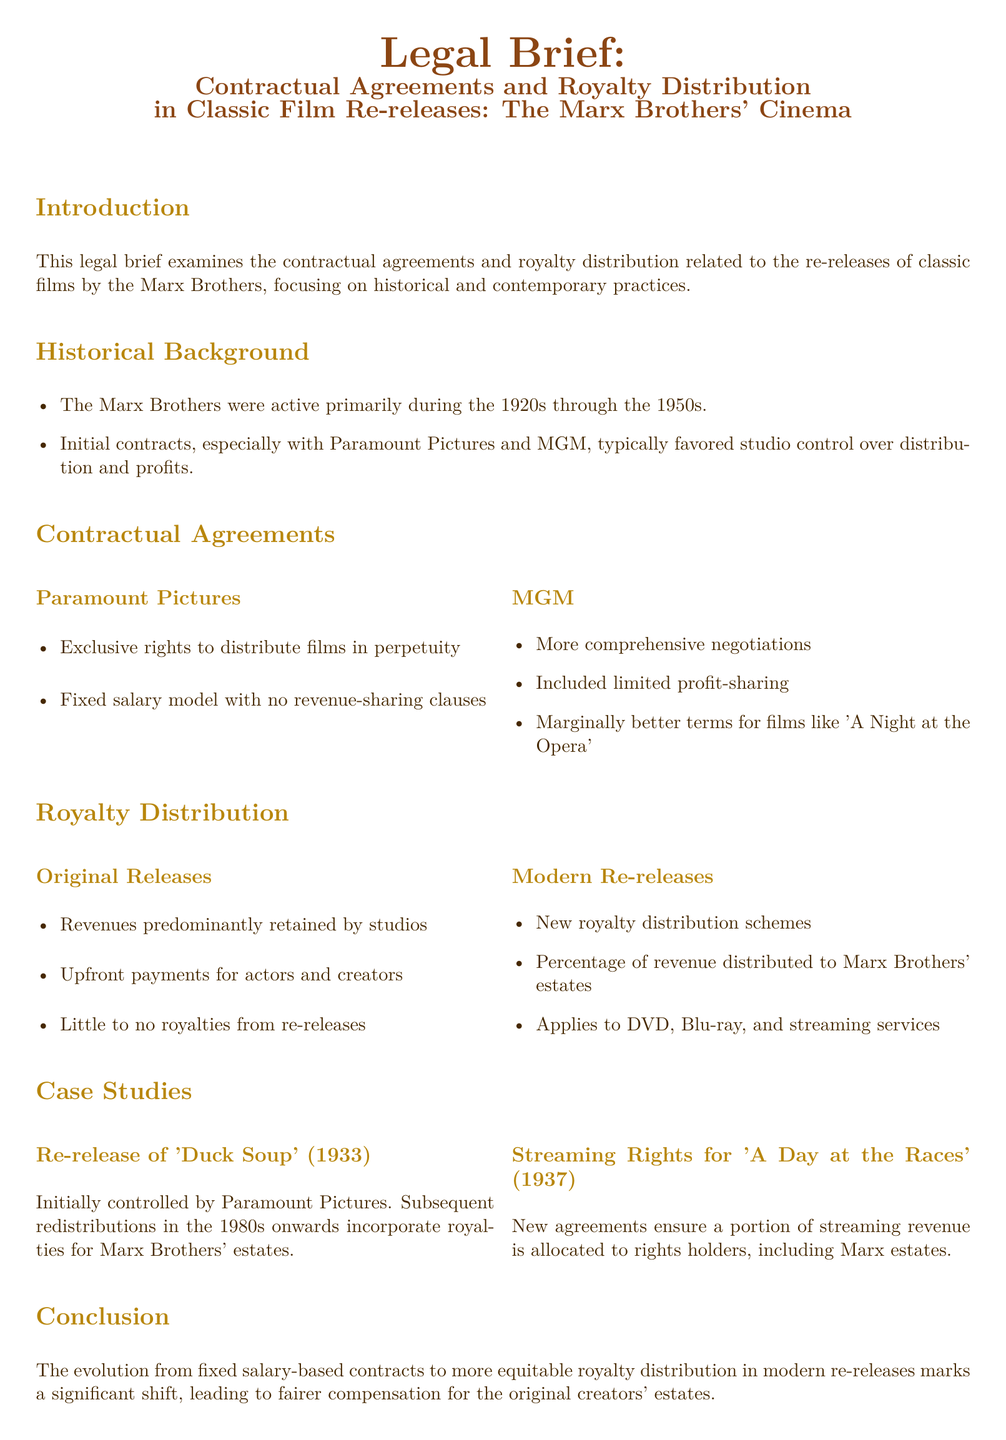What was the primary active period of the Marx Brothers? The document mentions that the Marx Brothers were active primarily during the 1920s through the 1950s.
Answer: 1920s through the 1950s Which studio had exclusive rights to distribute the Marx Brothers' films? The brief states that Paramount Pictures had exclusive rights to distribute the films in perpetuity.
Answer: Paramount Pictures What type of revenue-sharing model did the contracts with Paramount typically follow? The document specifies a fixed salary model with no revenue-sharing clauses.
Answer: Fixed salary model What film had marginally better terms under MGM's negotiations? The brief cites 'A Night at the Opera' as having marginally better terms.
Answer: A Night at the Opera What percentage of revenue is distributed to the Marx Brothers' estates in modern re-releases? The document indicates that new royalty distribution schemes ensure a percentage of revenue is distributed to Marx Brothers' estates.
Answer: Percentage of revenue What marked a significant shift in compensation for original creators' estates? The transition from fixed salary-based contracts to more equitable royalty distribution in modern re-releases marked a significant shift.
Answer: Significant shift What key case study is mentioned for the re-release of a 1933 film? The brief refers to 'Duck Soup' (1933) as a key case study for re-release.
Answer: Duck Soup Which 1937 film's streaming rights are addressed in the brief? The document mentions 'A Day at the Races' (1937) in the context of streaming rights.
Answer: A Day at the Races What type of legal document is this? The content is structured as a legal brief focusing on contractual agreements and royalty distribution.
Answer: Legal brief 